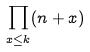Convert formula to latex. <formula><loc_0><loc_0><loc_500><loc_500>\prod _ { x \leq k } ( n + x )</formula> 